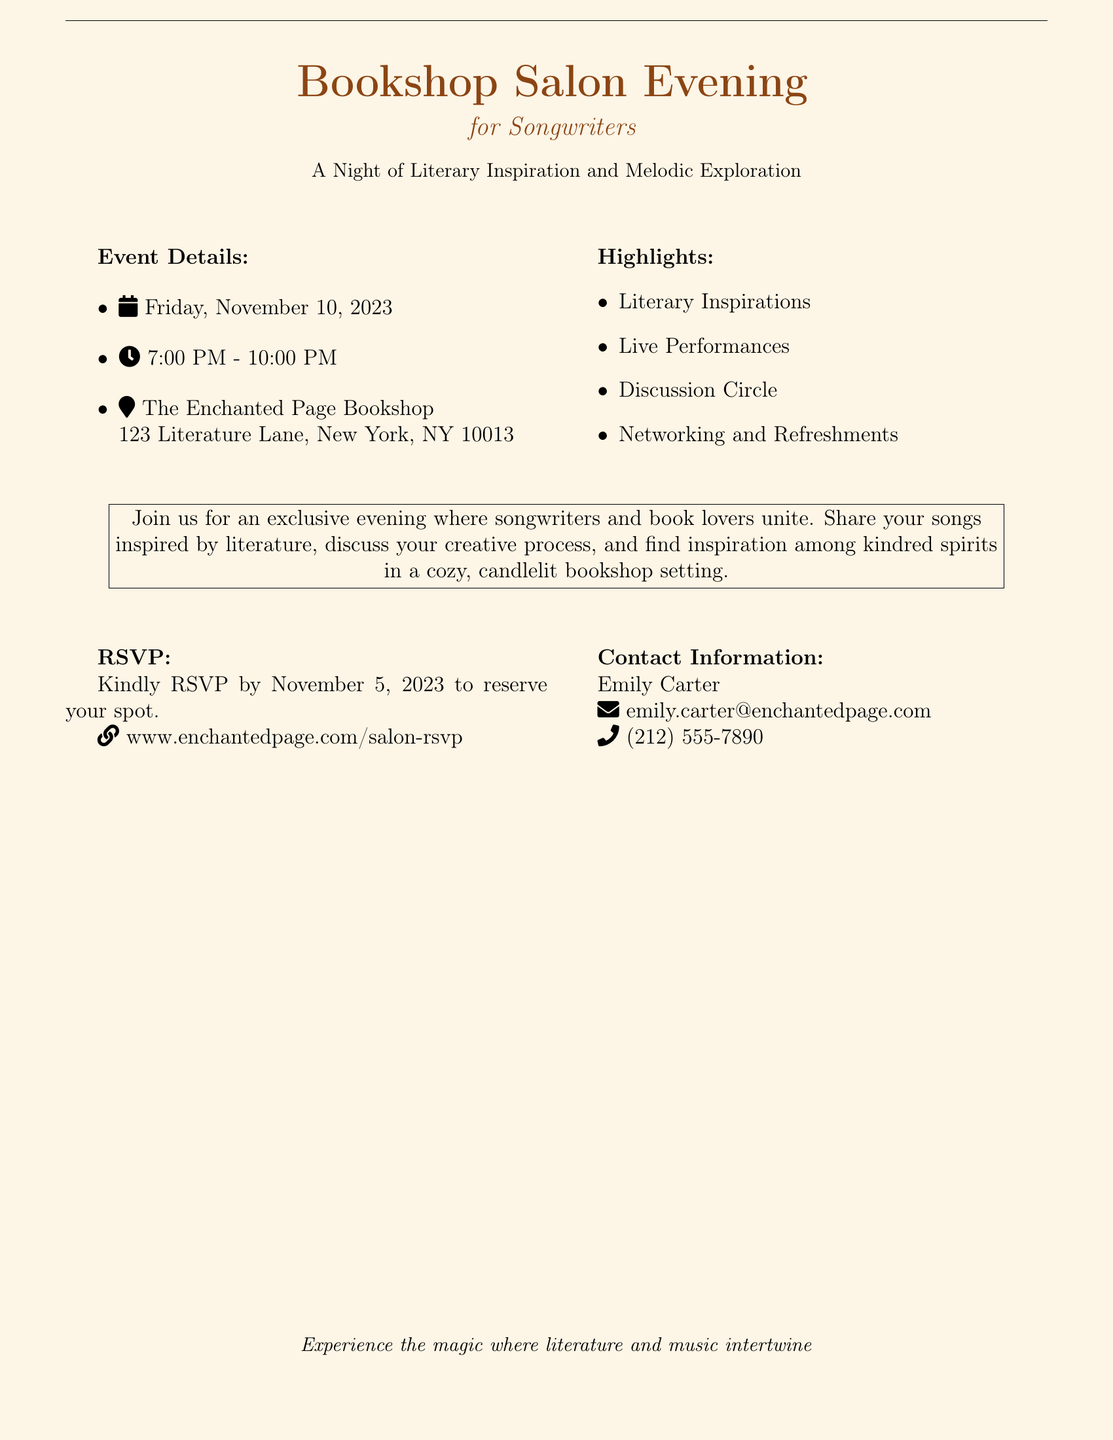What is the date of the event? The date of the event is specified in the document as November 10, 2023.
Answer: November 10, 2023 What time does the event start? The document states that the event starts at 7:00 PM.
Answer: 7:00 PM Who is the contact person for the event? The document lists Emily Carter as the contact person for the event.
Answer: Emily Carter What is the venue of the event? The venue is provided as The Enchanted Page Bookshop, located at 123 Literature Lane, New York, NY 10013.
Answer: The Enchanted Page Bookshop What is the RSVP deadline? The RSVP deadline is clearly stated as November 5, 2023.
Answer: November 5, 2023 What types of activities are highlighted in the document? The highlights include Literary Inspirations, Live Performances, Discussion Circle, and Networking and Refreshments.
Answer: Literary Inspirations, Live Performances, Discussion Circle, Networking and Refreshments How many hours will the event last? The event spans from 7:00 PM to 10:00 PM, which indicates it will last for three hours.
Answer: Three hours What is the theme of the event? The theme of the event is indicated by the phrase "A Night of Literary Inspiration and Melodic Exploration."
Answer: Literary Inspiration and Melodic Exploration How can attendees RSVP? Attendees can RSVP through the provided website link in the document.
Answer: www.enchantedpage.com/salon-rsvp 